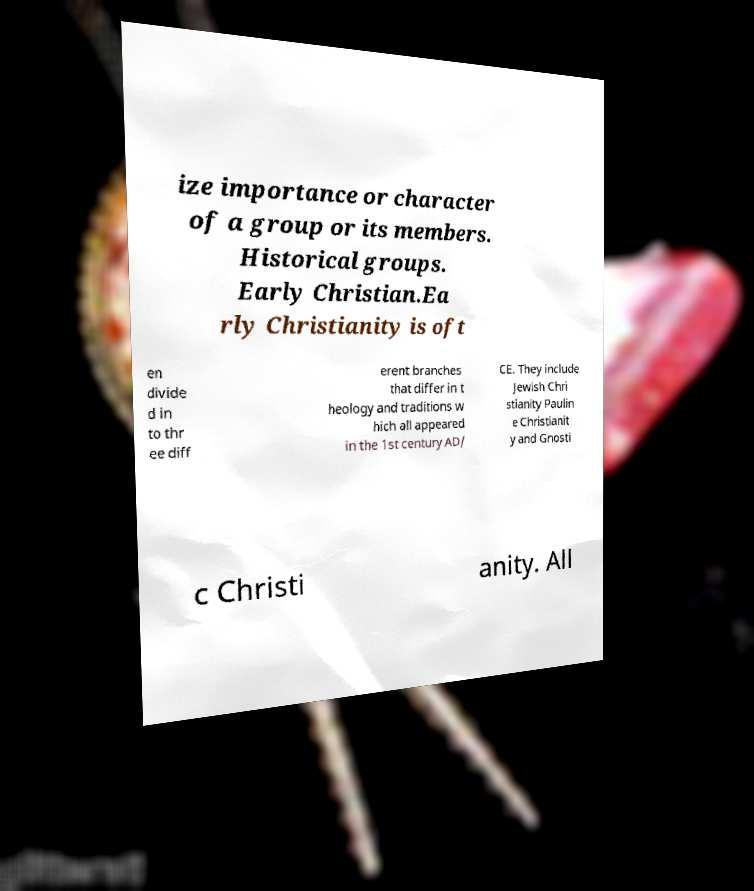Could you extract and type out the text from this image? ize importance or character of a group or its members. Historical groups. Early Christian.Ea rly Christianity is oft en divide d in to thr ee diff erent branches that differ in t heology and traditions w hich all appeared in the 1st century AD/ CE. They include Jewish Chri stianity Paulin e Christianit y and Gnosti c Christi anity. All 